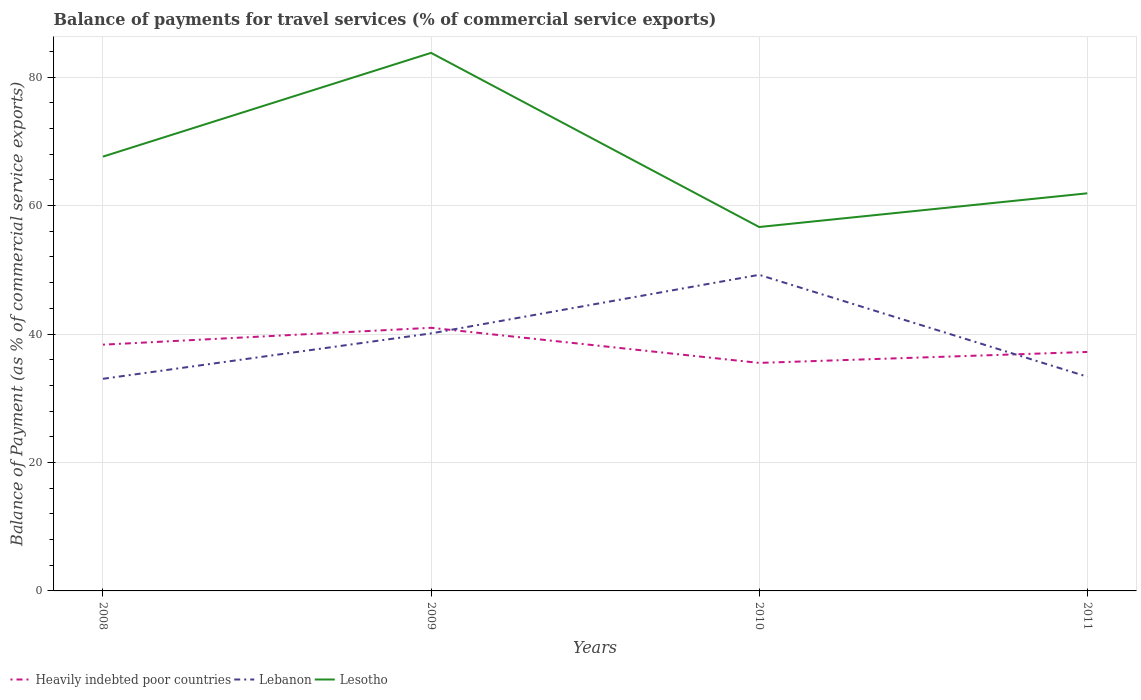Across all years, what is the maximum balance of payments for travel services in Heavily indebted poor countries?
Make the answer very short. 35.5. What is the total balance of payments for travel services in Lesotho in the graph?
Your response must be concise. 21.87. What is the difference between the highest and the second highest balance of payments for travel services in Heavily indebted poor countries?
Ensure brevity in your answer.  5.47. What is the difference between the highest and the lowest balance of payments for travel services in Lebanon?
Offer a very short reply. 2. Is the balance of payments for travel services in Lebanon strictly greater than the balance of payments for travel services in Heavily indebted poor countries over the years?
Your answer should be compact. No. What is the difference between two consecutive major ticks on the Y-axis?
Make the answer very short. 20. Are the values on the major ticks of Y-axis written in scientific E-notation?
Provide a short and direct response. No. Does the graph contain any zero values?
Your response must be concise. No. Where does the legend appear in the graph?
Your response must be concise. Bottom left. How many legend labels are there?
Your answer should be compact. 3. What is the title of the graph?
Keep it short and to the point. Balance of payments for travel services (% of commercial service exports). What is the label or title of the Y-axis?
Offer a very short reply. Balance of Payment (as % of commercial service exports). What is the Balance of Payment (as % of commercial service exports) of Heavily indebted poor countries in 2008?
Provide a succinct answer. 38.34. What is the Balance of Payment (as % of commercial service exports) of Lebanon in 2008?
Ensure brevity in your answer.  33.03. What is the Balance of Payment (as % of commercial service exports) of Lesotho in 2008?
Keep it short and to the point. 67.62. What is the Balance of Payment (as % of commercial service exports) in Heavily indebted poor countries in 2009?
Your answer should be very brief. 40.97. What is the Balance of Payment (as % of commercial service exports) in Lebanon in 2009?
Offer a terse response. 40.09. What is the Balance of Payment (as % of commercial service exports) of Lesotho in 2009?
Your response must be concise. 83.77. What is the Balance of Payment (as % of commercial service exports) of Heavily indebted poor countries in 2010?
Ensure brevity in your answer.  35.5. What is the Balance of Payment (as % of commercial service exports) in Lebanon in 2010?
Offer a terse response. 49.22. What is the Balance of Payment (as % of commercial service exports) in Lesotho in 2010?
Your answer should be compact. 56.66. What is the Balance of Payment (as % of commercial service exports) of Heavily indebted poor countries in 2011?
Provide a succinct answer. 37.21. What is the Balance of Payment (as % of commercial service exports) in Lebanon in 2011?
Your response must be concise. 33.36. What is the Balance of Payment (as % of commercial service exports) in Lesotho in 2011?
Provide a succinct answer. 61.91. Across all years, what is the maximum Balance of Payment (as % of commercial service exports) in Heavily indebted poor countries?
Give a very brief answer. 40.97. Across all years, what is the maximum Balance of Payment (as % of commercial service exports) in Lebanon?
Provide a short and direct response. 49.22. Across all years, what is the maximum Balance of Payment (as % of commercial service exports) of Lesotho?
Provide a short and direct response. 83.77. Across all years, what is the minimum Balance of Payment (as % of commercial service exports) of Heavily indebted poor countries?
Give a very brief answer. 35.5. Across all years, what is the minimum Balance of Payment (as % of commercial service exports) of Lebanon?
Keep it short and to the point. 33.03. Across all years, what is the minimum Balance of Payment (as % of commercial service exports) of Lesotho?
Provide a short and direct response. 56.66. What is the total Balance of Payment (as % of commercial service exports) of Heavily indebted poor countries in the graph?
Your answer should be very brief. 152.02. What is the total Balance of Payment (as % of commercial service exports) of Lebanon in the graph?
Ensure brevity in your answer.  155.69. What is the total Balance of Payment (as % of commercial service exports) of Lesotho in the graph?
Ensure brevity in your answer.  269.96. What is the difference between the Balance of Payment (as % of commercial service exports) of Heavily indebted poor countries in 2008 and that in 2009?
Make the answer very short. -2.63. What is the difference between the Balance of Payment (as % of commercial service exports) of Lebanon in 2008 and that in 2009?
Keep it short and to the point. -7.07. What is the difference between the Balance of Payment (as % of commercial service exports) in Lesotho in 2008 and that in 2009?
Give a very brief answer. -16.15. What is the difference between the Balance of Payment (as % of commercial service exports) in Heavily indebted poor countries in 2008 and that in 2010?
Provide a short and direct response. 2.84. What is the difference between the Balance of Payment (as % of commercial service exports) in Lebanon in 2008 and that in 2010?
Provide a succinct answer. -16.19. What is the difference between the Balance of Payment (as % of commercial service exports) of Lesotho in 2008 and that in 2010?
Offer a very short reply. 10.96. What is the difference between the Balance of Payment (as % of commercial service exports) of Heavily indebted poor countries in 2008 and that in 2011?
Your answer should be very brief. 1.13. What is the difference between the Balance of Payment (as % of commercial service exports) in Lebanon in 2008 and that in 2011?
Your response must be concise. -0.33. What is the difference between the Balance of Payment (as % of commercial service exports) of Lesotho in 2008 and that in 2011?
Your answer should be compact. 5.71. What is the difference between the Balance of Payment (as % of commercial service exports) in Heavily indebted poor countries in 2009 and that in 2010?
Make the answer very short. 5.47. What is the difference between the Balance of Payment (as % of commercial service exports) of Lebanon in 2009 and that in 2010?
Ensure brevity in your answer.  -9.12. What is the difference between the Balance of Payment (as % of commercial service exports) of Lesotho in 2009 and that in 2010?
Your answer should be very brief. 27.11. What is the difference between the Balance of Payment (as % of commercial service exports) in Heavily indebted poor countries in 2009 and that in 2011?
Offer a very short reply. 3.76. What is the difference between the Balance of Payment (as % of commercial service exports) of Lebanon in 2009 and that in 2011?
Offer a very short reply. 6.74. What is the difference between the Balance of Payment (as % of commercial service exports) of Lesotho in 2009 and that in 2011?
Offer a very short reply. 21.87. What is the difference between the Balance of Payment (as % of commercial service exports) of Heavily indebted poor countries in 2010 and that in 2011?
Offer a terse response. -1.71. What is the difference between the Balance of Payment (as % of commercial service exports) in Lebanon in 2010 and that in 2011?
Ensure brevity in your answer.  15.86. What is the difference between the Balance of Payment (as % of commercial service exports) in Lesotho in 2010 and that in 2011?
Provide a succinct answer. -5.25. What is the difference between the Balance of Payment (as % of commercial service exports) of Heavily indebted poor countries in 2008 and the Balance of Payment (as % of commercial service exports) of Lebanon in 2009?
Provide a short and direct response. -1.76. What is the difference between the Balance of Payment (as % of commercial service exports) of Heavily indebted poor countries in 2008 and the Balance of Payment (as % of commercial service exports) of Lesotho in 2009?
Offer a terse response. -45.43. What is the difference between the Balance of Payment (as % of commercial service exports) of Lebanon in 2008 and the Balance of Payment (as % of commercial service exports) of Lesotho in 2009?
Your answer should be compact. -50.75. What is the difference between the Balance of Payment (as % of commercial service exports) of Heavily indebted poor countries in 2008 and the Balance of Payment (as % of commercial service exports) of Lebanon in 2010?
Keep it short and to the point. -10.88. What is the difference between the Balance of Payment (as % of commercial service exports) of Heavily indebted poor countries in 2008 and the Balance of Payment (as % of commercial service exports) of Lesotho in 2010?
Provide a succinct answer. -18.32. What is the difference between the Balance of Payment (as % of commercial service exports) of Lebanon in 2008 and the Balance of Payment (as % of commercial service exports) of Lesotho in 2010?
Your answer should be compact. -23.63. What is the difference between the Balance of Payment (as % of commercial service exports) in Heavily indebted poor countries in 2008 and the Balance of Payment (as % of commercial service exports) in Lebanon in 2011?
Give a very brief answer. 4.98. What is the difference between the Balance of Payment (as % of commercial service exports) of Heavily indebted poor countries in 2008 and the Balance of Payment (as % of commercial service exports) of Lesotho in 2011?
Your answer should be compact. -23.57. What is the difference between the Balance of Payment (as % of commercial service exports) of Lebanon in 2008 and the Balance of Payment (as % of commercial service exports) of Lesotho in 2011?
Offer a terse response. -28.88. What is the difference between the Balance of Payment (as % of commercial service exports) in Heavily indebted poor countries in 2009 and the Balance of Payment (as % of commercial service exports) in Lebanon in 2010?
Keep it short and to the point. -8.25. What is the difference between the Balance of Payment (as % of commercial service exports) in Heavily indebted poor countries in 2009 and the Balance of Payment (as % of commercial service exports) in Lesotho in 2010?
Offer a very short reply. -15.69. What is the difference between the Balance of Payment (as % of commercial service exports) in Lebanon in 2009 and the Balance of Payment (as % of commercial service exports) in Lesotho in 2010?
Offer a very short reply. -16.56. What is the difference between the Balance of Payment (as % of commercial service exports) in Heavily indebted poor countries in 2009 and the Balance of Payment (as % of commercial service exports) in Lebanon in 2011?
Offer a very short reply. 7.61. What is the difference between the Balance of Payment (as % of commercial service exports) in Heavily indebted poor countries in 2009 and the Balance of Payment (as % of commercial service exports) in Lesotho in 2011?
Ensure brevity in your answer.  -20.94. What is the difference between the Balance of Payment (as % of commercial service exports) of Lebanon in 2009 and the Balance of Payment (as % of commercial service exports) of Lesotho in 2011?
Your response must be concise. -21.81. What is the difference between the Balance of Payment (as % of commercial service exports) of Heavily indebted poor countries in 2010 and the Balance of Payment (as % of commercial service exports) of Lebanon in 2011?
Offer a very short reply. 2.15. What is the difference between the Balance of Payment (as % of commercial service exports) of Heavily indebted poor countries in 2010 and the Balance of Payment (as % of commercial service exports) of Lesotho in 2011?
Your answer should be compact. -26.4. What is the difference between the Balance of Payment (as % of commercial service exports) of Lebanon in 2010 and the Balance of Payment (as % of commercial service exports) of Lesotho in 2011?
Your response must be concise. -12.69. What is the average Balance of Payment (as % of commercial service exports) in Heavily indebted poor countries per year?
Provide a short and direct response. 38. What is the average Balance of Payment (as % of commercial service exports) of Lebanon per year?
Make the answer very short. 38.92. What is the average Balance of Payment (as % of commercial service exports) in Lesotho per year?
Provide a succinct answer. 67.49. In the year 2008, what is the difference between the Balance of Payment (as % of commercial service exports) in Heavily indebted poor countries and Balance of Payment (as % of commercial service exports) in Lebanon?
Keep it short and to the point. 5.31. In the year 2008, what is the difference between the Balance of Payment (as % of commercial service exports) in Heavily indebted poor countries and Balance of Payment (as % of commercial service exports) in Lesotho?
Keep it short and to the point. -29.28. In the year 2008, what is the difference between the Balance of Payment (as % of commercial service exports) of Lebanon and Balance of Payment (as % of commercial service exports) of Lesotho?
Your answer should be compact. -34.59. In the year 2009, what is the difference between the Balance of Payment (as % of commercial service exports) in Heavily indebted poor countries and Balance of Payment (as % of commercial service exports) in Lebanon?
Make the answer very short. 0.87. In the year 2009, what is the difference between the Balance of Payment (as % of commercial service exports) of Heavily indebted poor countries and Balance of Payment (as % of commercial service exports) of Lesotho?
Your answer should be very brief. -42.8. In the year 2009, what is the difference between the Balance of Payment (as % of commercial service exports) of Lebanon and Balance of Payment (as % of commercial service exports) of Lesotho?
Your answer should be very brief. -43.68. In the year 2010, what is the difference between the Balance of Payment (as % of commercial service exports) in Heavily indebted poor countries and Balance of Payment (as % of commercial service exports) in Lebanon?
Give a very brief answer. -13.71. In the year 2010, what is the difference between the Balance of Payment (as % of commercial service exports) of Heavily indebted poor countries and Balance of Payment (as % of commercial service exports) of Lesotho?
Make the answer very short. -21.16. In the year 2010, what is the difference between the Balance of Payment (as % of commercial service exports) in Lebanon and Balance of Payment (as % of commercial service exports) in Lesotho?
Provide a succinct answer. -7.44. In the year 2011, what is the difference between the Balance of Payment (as % of commercial service exports) in Heavily indebted poor countries and Balance of Payment (as % of commercial service exports) in Lebanon?
Make the answer very short. 3.85. In the year 2011, what is the difference between the Balance of Payment (as % of commercial service exports) in Heavily indebted poor countries and Balance of Payment (as % of commercial service exports) in Lesotho?
Make the answer very short. -24.7. In the year 2011, what is the difference between the Balance of Payment (as % of commercial service exports) of Lebanon and Balance of Payment (as % of commercial service exports) of Lesotho?
Make the answer very short. -28.55. What is the ratio of the Balance of Payment (as % of commercial service exports) in Heavily indebted poor countries in 2008 to that in 2009?
Your answer should be very brief. 0.94. What is the ratio of the Balance of Payment (as % of commercial service exports) in Lebanon in 2008 to that in 2009?
Offer a terse response. 0.82. What is the ratio of the Balance of Payment (as % of commercial service exports) in Lesotho in 2008 to that in 2009?
Offer a very short reply. 0.81. What is the ratio of the Balance of Payment (as % of commercial service exports) of Heavily indebted poor countries in 2008 to that in 2010?
Make the answer very short. 1.08. What is the ratio of the Balance of Payment (as % of commercial service exports) in Lebanon in 2008 to that in 2010?
Provide a succinct answer. 0.67. What is the ratio of the Balance of Payment (as % of commercial service exports) in Lesotho in 2008 to that in 2010?
Ensure brevity in your answer.  1.19. What is the ratio of the Balance of Payment (as % of commercial service exports) in Heavily indebted poor countries in 2008 to that in 2011?
Provide a short and direct response. 1.03. What is the ratio of the Balance of Payment (as % of commercial service exports) in Lebanon in 2008 to that in 2011?
Keep it short and to the point. 0.99. What is the ratio of the Balance of Payment (as % of commercial service exports) in Lesotho in 2008 to that in 2011?
Offer a terse response. 1.09. What is the ratio of the Balance of Payment (as % of commercial service exports) in Heavily indebted poor countries in 2009 to that in 2010?
Provide a succinct answer. 1.15. What is the ratio of the Balance of Payment (as % of commercial service exports) in Lebanon in 2009 to that in 2010?
Ensure brevity in your answer.  0.81. What is the ratio of the Balance of Payment (as % of commercial service exports) of Lesotho in 2009 to that in 2010?
Your response must be concise. 1.48. What is the ratio of the Balance of Payment (as % of commercial service exports) in Heavily indebted poor countries in 2009 to that in 2011?
Offer a terse response. 1.1. What is the ratio of the Balance of Payment (as % of commercial service exports) of Lebanon in 2009 to that in 2011?
Offer a very short reply. 1.2. What is the ratio of the Balance of Payment (as % of commercial service exports) of Lesotho in 2009 to that in 2011?
Offer a terse response. 1.35. What is the ratio of the Balance of Payment (as % of commercial service exports) in Heavily indebted poor countries in 2010 to that in 2011?
Provide a short and direct response. 0.95. What is the ratio of the Balance of Payment (as % of commercial service exports) of Lebanon in 2010 to that in 2011?
Keep it short and to the point. 1.48. What is the ratio of the Balance of Payment (as % of commercial service exports) of Lesotho in 2010 to that in 2011?
Your answer should be compact. 0.92. What is the difference between the highest and the second highest Balance of Payment (as % of commercial service exports) of Heavily indebted poor countries?
Provide a succinct answer. 2.63. What is the difference between the highest and the second highest Balance of Payment (as % of commercial service exports) of Lebanon?
Your response must be concise. 9.12. What is the difference between the highest and the second highest Balance of Payment (as % of commercial service exports) in Lesotho?
Ensure brevity in your answer.  16.15. What is the difference between the highest and the lowest Balance of Payment (as % of commercial service exports) of Heavily indebted poor countries?
Ensure brevity in your answer.  5.47. What is the difference between the highest and the lowest Balance of Payment (as % of commercial service exports) of Lebanon?
Your answer should be very brief. 16.19. What is the difference between the highest and the lowest Balance of Payment (as % of commercial service exports) in Lesotho?
Offer a very short reply. 27.11. 